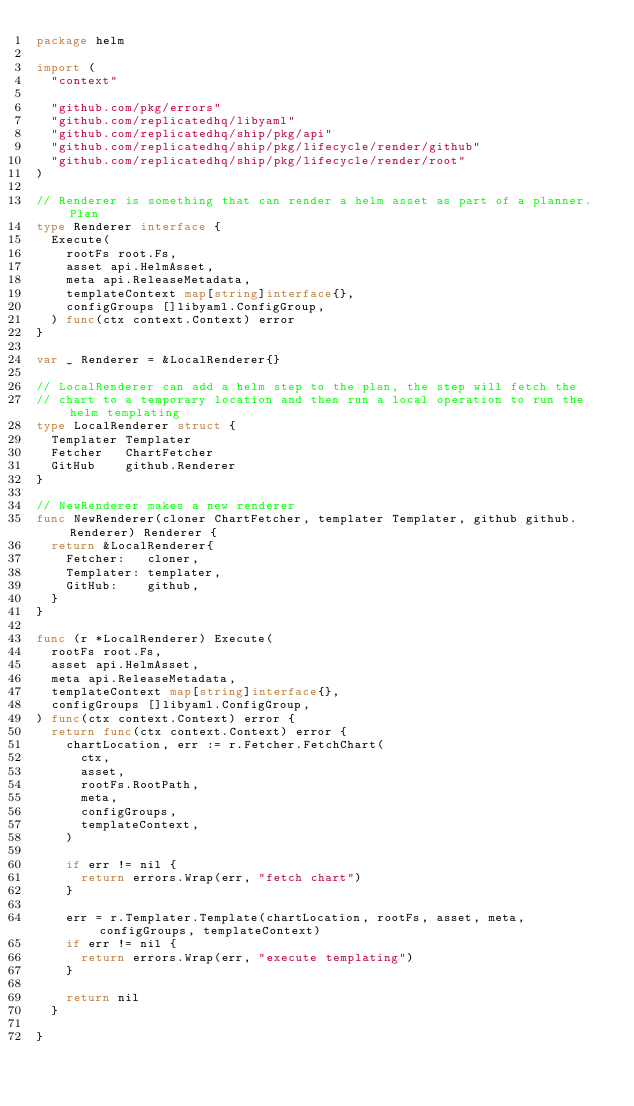<code> <loc_0><loc_0><loc_500><loc_500><_Go_>package helm

import (
	"context"

	"github.com/pkg/errors"
	"github.com/replicatedhq/libyaml"
	"github.com/replicatedhq/ship/pkg/api"
	"github.com/replicatedhq/ship/pkg/lifecycle/render/github"
	"github.com/replicatedhq/ship/pkg/lifecycle/render/root"
)

// Renderer is something that can render a helm asset as part of a planner.Plan
type Renderer interface {
	Execute(
		rootFs root.Fs,
		asset api.HelmAsset,
		meta api.ReleaseMetadata,
		templateContext map[string]interface{},
		configGroups []libyaml.ConfigGroup,
	) func(ctx context.Context) error
}

var _ Renderer = &LocalRenderer{}

// LocalRenderer can add a helm step to the plan, the step will fetch the
// chart to a temporary location and then run a local operation to run the helm templating
type LocalRenderer struct {
	Templater Templater
	Fetcher   ChartFetcher
	GitHub    github.Renderer
}

// NewRenderer makes a new renderer
func NewRenderer(cloner ChartFetcher, templater Templater, github github.Renderer) Renderer {
	return &LocalRenderer{
		Fetcher:   cloner,
		Templater: templater,
		GitHub:    github,
	}
}

func (r *LocalRenderer) Execute(
	rootFs root.Fs,
	asset api.HelmAsset,
	meta api.ReleaseMetadata,
	templateContext map[string]interface{},
	configGroups []libyaml.ConfigGroup,
) func(ctx context.Context) error {
	return func(ctx context.Context) error {
		chartLocation, err := r.Fetcher.FetchChart(
			ctx,
			asset,
			rootFs.RootPath,
			meta,
			configGroups,
			templateContext,
		)

		if err != nil {
			return errors.Wrap(err, "fetch chart")
		}

		err = r.Templater.Template(chartLocation, rootFs, asset, meta, configGroups, templateContext)
		if err != nil {
			return errors.Wrap(err, "execute templating")
		}

		return nil
	}

}
</code> 